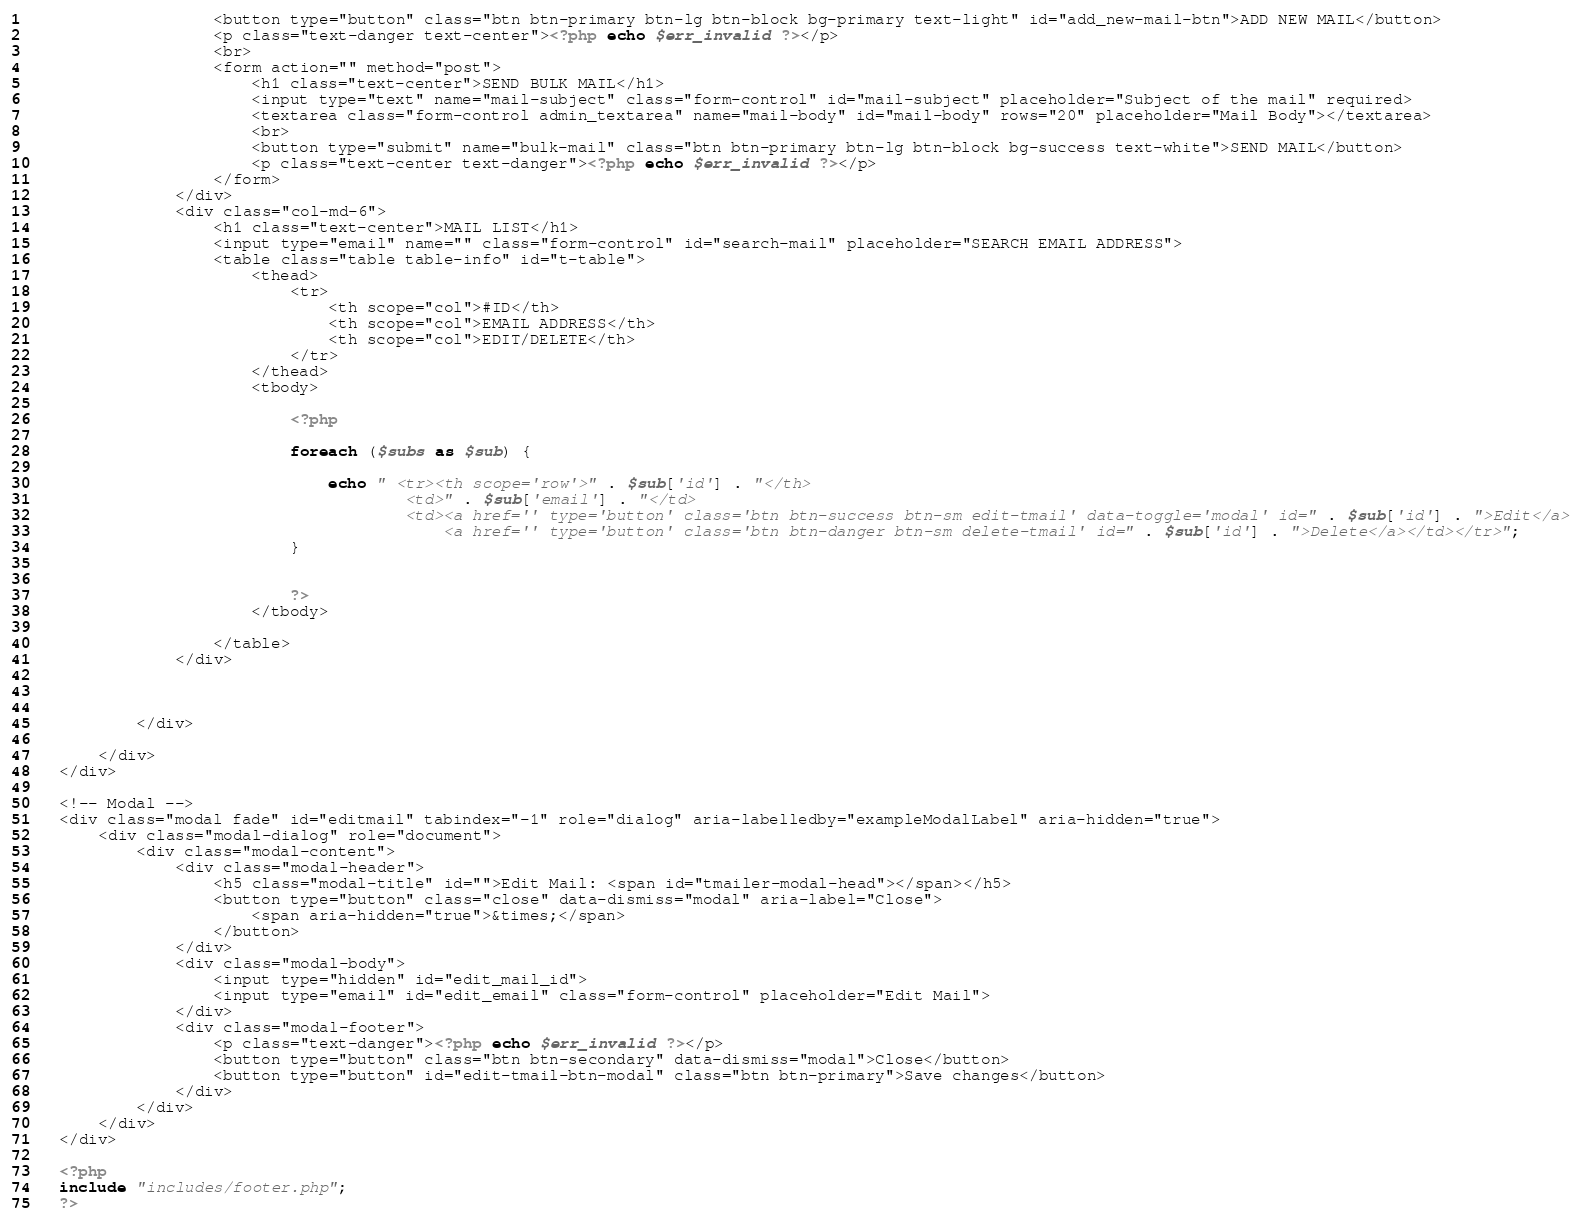Convert code to text. <code><loc_0><loc_0><loc_500><loc_500><_PHP_>                    <button type="button" class="btn btn-primary btn-lg btn-block bg-primary text-light" id="add_new-mail-btn">ADD NEW MAIL</button>
                    <p class="text-danger text-center"><?php echo $err_invalid ?></p>
                    <br>
                    <form action="" method="post">
                        <h1 class="text-center">SEND BULK MAIL</h1>
                        <input type="text" name="mail-subject" class="form-control" id="mail-subject" placeholder="Subject of the mail" required>
                        <textarea class="form-control admin_textarea" name="mail-body" id="mail-body" rows="20" placeholder="Mail Body"></textarea>
                        <br>
                        <button type="submit" name="bulk-mail" class="btn btn-primary btn-lg btn-block bg-success text-white">SEND MAIL</button>
                        <p class="text-center text-danger"><?php echo $err_invalid ?></p>
                    </form>
                </div>
                <div class="col-md-6">
                    <h1 class="text-center">MAIL LIST</h1>
                    <input type="email" name="" class="form-control" id="search-mail" placeholder="SEARCH EMAIL ADDRESS">
                    <table class="table table-info" id="t-table">
                        <thead>
                            <tr>
                                <th scope="col">#ID</th>
                                <th scope="col">EMAIL ADDRESS</th>
                                <th scope="col">EDIT/DELETE</th>
                            </tr>
                        </thead>
                        <tbody>

                            <?php

                            foreach ($subs as $sub) {

                                echo " <tr><th scope='row'>" . $sub['id'] . "</th>
                                        <td>" . $sub['email'] . "</td>
                                        <td><a href='' type='button' class='btn btn-success btn-sm edit-tmail' data-toggle='modal' id=" . $sub['id'] . ">Edit</a>
                                            <a href='' type='button' class='btn btn-danger btn-sm delete-tmail' id=" . $sub['id'] . ">Delete</a></td></tr>";
                            }


                            ?>
                        </tbody>

                    </table>
                </div>



            </div>

        </div>
    </div>

    <!-- Modal -->
    <div class="modal fade" id="editmail" tabindex="-1" role="dialog" aria-labelledby="exampleModalLabel" aria-hidden="true">
        <div class="modal-dialog" role="document">
            <div class="modal-content">
                <div class="modal-header">
                    <h5 class="modal-title" id="">Edit Mail: <span id="tmailer-modal-head"></span></h5>
                    <button type="button" class="close" data-dismiss="modal" aria-label="Close">
                        <span aria-hidden="true">&times;</span>
                    </button>
                </div>
                <div class="modal-body">
                    <input type="hidden" id="edit_mail_id">
                    <input type="email" id="edit_email" class="form-control" placeholder="Edit Mail">
                </div>
                <div class="modal-footer">
                    <p class="text-danger"><?php echo $err_invalid ?></p>
                    <button type="button" class="btn btn-secondary" data-dismiss="modal">Close</button>
                    <button type="button" id="edit-tmail-btn-modal" class="btn btn-primary">Save changes</button>
                </div>
            </div>
        </div>
    </div>

    <?php
    include "includes/footer.php";
    ?></code> 